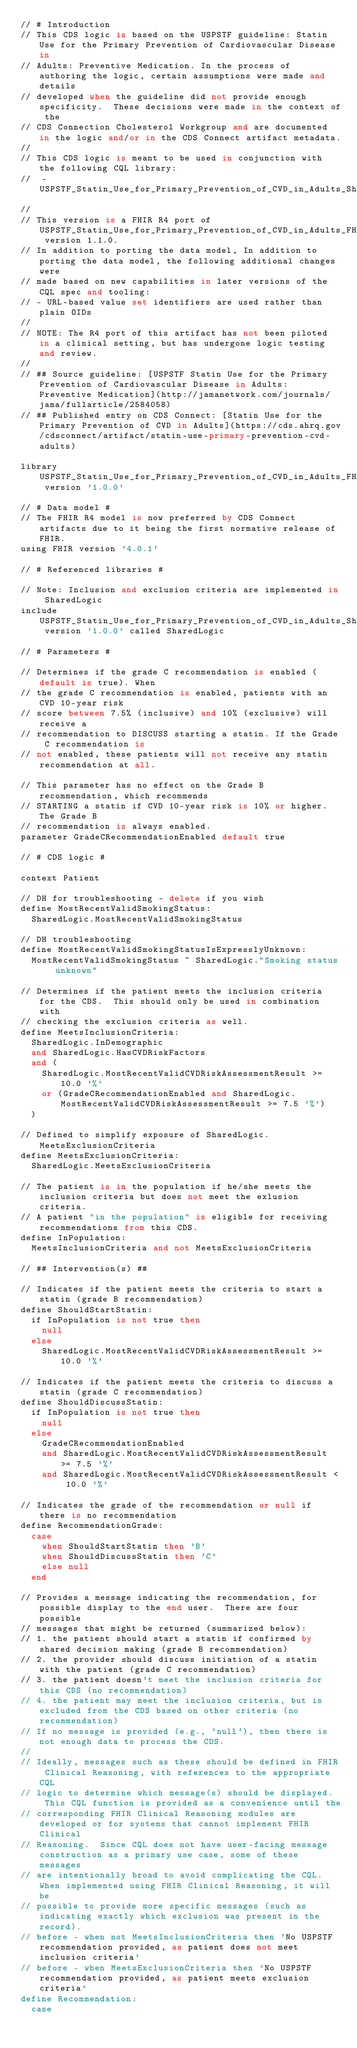<code> <loc_0><loc_0><loc_500><loc_500><_SQL_>// # Introduction
// This CDS logic is based on the USPSTF guideline: Statin Use for the Primary Prevention of Cardiovascular Disease in
// Adults: Preventive Medication. In the process of authoring the logic, certain assumptions were made and details
// developed when the guideline did not provide enough specificity.  These decisions were made in the context of the
// CDS Connection Cholesterol Workgroup and are documented in the logic and/or in the CDS Connect artifact metadata.
//
// This CDS logic is meant to be used in conjunction with the following CQL library:
//  - USPSTF_Statin_Use_for_Primary_Prevention_of_CVD_in_Adults_Shared_Logic_FHIRv401
//
// This version is a FHIR R4 port of USPSTF_Statin_Use_for_Primary_Prevention_of_CVD_in_Adults_FHIRv102 version 1.1.0.
// In addition to porting the data model, In addition to porting the data model, the following additional changes were
// made based on new capabilities in later versions of the CQL spec and tooling:
// - URL-based value set identifiers are used rather than plain OIDs
//
// NOTE: The R4 port of this artifact has not been piloted in a clinical setting, but has undergone logic testing and review.
//
// ## Source guideline: [USPSTF Statin Use for the Primary Prevention of Cardiovascular Disease in Adults: Preventive Medication](http://jamanetwork.com/journals/jama/fullarticle/2584058)
// ## Published entry on CDS Connect: [Statin Use for the Primary Prevention of CVD in Adults](https://cds.ahrq.gov/cdsconnect/artifact/statin-use-primary-prevention-cvd-adults)

library USPSTF_Statin_Use_for_Primary_Prevention_of_CVD_in_Adults_FHIRv401 version '1.0.0'

// # Data model #
// The FHIR R4 model is now preferred by CDS Connect artifacts due to it being the first normative release of FHIR.
using FHIR version '4.0.1'

// # Referenced libraries #

// Note: Inclusion and exclusion criteria are implemented in SharedLogic
include USPSTF_Statin_Use_for_Primary_Prevention_of_CVD_in_Adults_Shared_Logic_FHIRv401 version '1.0.0' called SharedLogic

// # Parameters #

// Determines if the grade C recommendation is enabled (default is true). When
// the grade C recommendation is enabled, patients with an CVD 10-year risk
// score between 7.5% (inclusive) and 10% (exclusive) will receive a
// recommendation to DISCUSS starting a statin. If the Grade C recommendation is
// not enabled, these patients will not receive any statin recommendation at all.

// This parameter has no effect on the Grade B recommendation, which recommends
// STARTING a statin if CVD 10-year risk is 10% or higher. The Grade B
// recommendation is always enabled.
parameter GradeCRecommendationEnabled default true

// # CDS logic #

context Patient

// DH for troubleshooting - delete if you wish
define MostRecentValidSmokingStatus:
  SharedLogic.MostRecentValidSmokingStatus

// DH troubleshooting
define MostRecentValidSmokingStatusIsExpresslyUnknown:
  MostRecentValidSmokingStatus ~ SharedLogic."Smoking status unknown"

// Determines if the patient meets the inclusion criteria for the CDS.  This should only be used in combination with
// checking the exclusion criteria as well.
define MeetsInclusionCriteria:
  SharedLogic.InDemographic
  and SharedLogic.HasCVDRiskFactors
  and (
    SharedLogic.MostRecentValidCVDRiskAssessmentResult >= 10.0 '%'
    or (GradeCRecommendationEnabled and SharedLogic.MostRecentValidCVDRiskAssessmentResult >= 7.5 '%')
  )

// Defined to simplify exposure of SharedLogic.MeetsExclusionCriteria
define MeetsExclusionCriteria:
  SharedLogic.MeetsExclusionCriteria

// The patient is in the population if he/she meets the inclusion criteria but does not meet the exlusion criteria.
// A patient "in the population" is eligible for receiving recommendations from this CDS.
define InPopulation:
  MeetsInclusionCriteria and not MeetsExclusionCriteria

// ## Intervention(s) ##

// Indicates if the patient meets the criteria to start a statin (grade B recommendation)
define ShouldStartStatin:
  if InPopulation is not true then
    null
  else
    SharedLogic.MostRecentValidCVDRiskAssessmentResult >= 10.0 '%'

// Indicates if the patient meets the criteria to discuss a statin (grade C recommendation)
define ShouldDiscussStatin:
  if InPopulation is not true then
    null
  else
    GradeCRecommendationEnabled
    and SharedLogic.MostRecentValidCVDRiskAssessmentResult >= 7.5 '%'
    and SharedLogic.MostRecentValidCVDRiskAssessmentResult < 10.0 '%'

// Indicates the grade of the recommendation or null if there is no recommendation
define RecommendationGrade:
  case
    when ShouldStartStatin then 'B'
    when ShouldDiscussStatin then 'C'
    else null
  end

// Provides a message indicating the recommendation, for possible display to the end user.  There are four possible
// messages that might be returned (summarized below):
// 1. the patient should start a statin if confirmed by shared decision making (grade B recommendation)
// 2. the provider should discuss initiation of a statin with the patient (grade C recommendation)
// 3. the patient doesn't meet the inclusion criteria for this CDS (no recommendation)
// 4. the patient may meet the inclusion criteria, but is excluded from the CDS based on other criteria (no recommendation)
// If no message is provided (e.g., `null`), then there is not enough data to process the CDS.
//
// Ideally, messages such as these should be defined in FHIR Clinical Reasoning, with references to the appropriate CQL
// logic to determine which message(s) should be displayed.  This CQL function is provided as a convenience until the
// corresponding FHIR Clinical Reasoning modules are developed or for systems that cannot implement FHIR Clinical
// Reasoning.  Since CQL does not have user-facing message construction as a primary use case, some of these messages
// are intentionally broad to avoid complicating the CQL.  When implemented using FHIR Clinical Reasoning, it will be
// possible to provide more specific messages (such as indicating exactly which exclusion was present in the record).
// before - when not MeetsInclusionCriteria then 'No USPSTF recommendation provided, as patient does not meet inclusion criteria'
// before - when MeetsExclusionCriteria then 'No USPSTF recommendation provided, as patient meets exclusion criteria'
define Recommendation:
  case</code> 